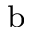Convert formula to latex. <formula><loc_0><loc_0><loc_500><loc_500>^ { b }</formula> 